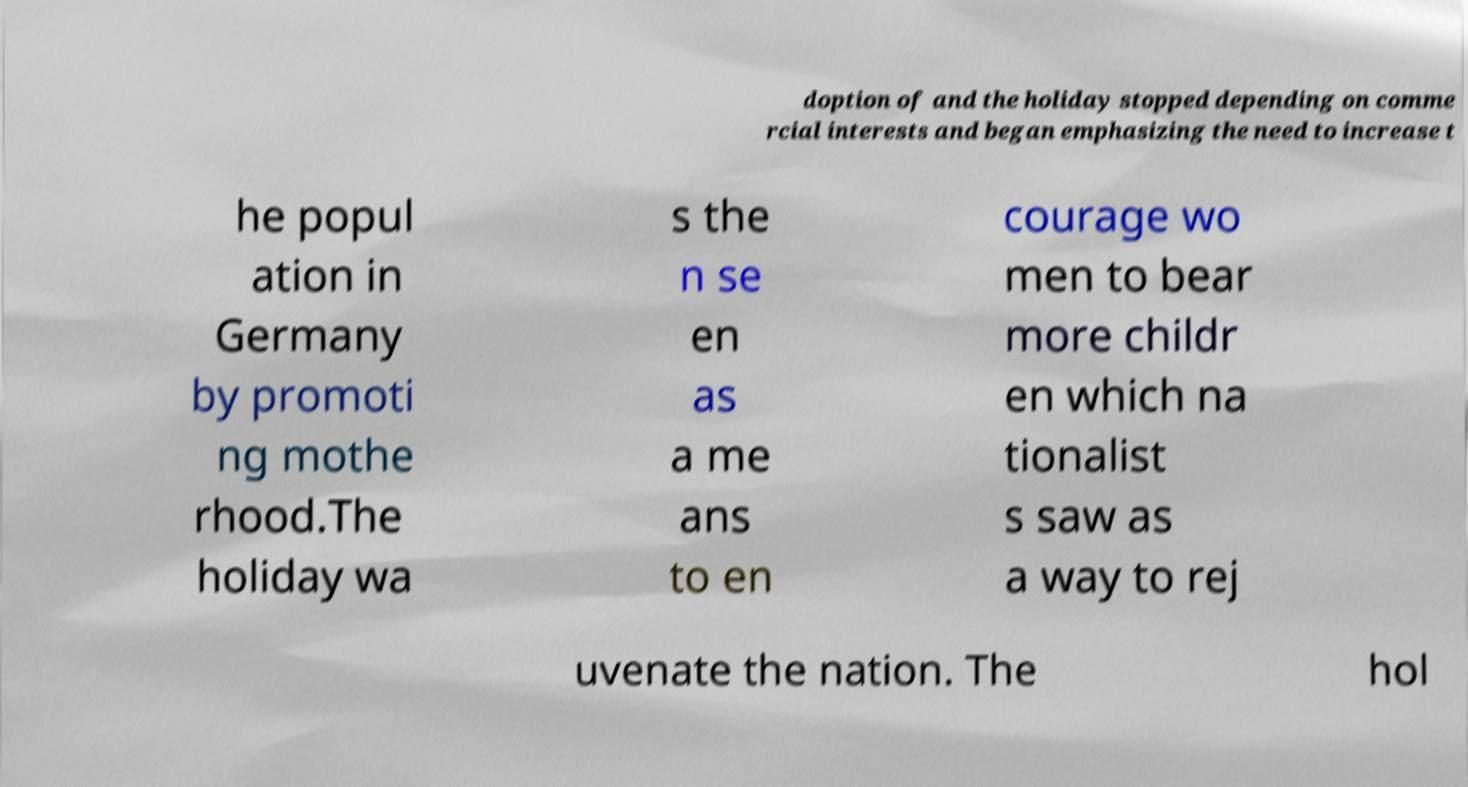There's text embedded in this image that I need extracted. Can you transcribe it verbatim? doption of and the holiday stopped depending on comme rcial interests and began emphasizing the need to increase t he popul ation in Germany by promoti ng mothe rhood.The holiday wa s the n se en as a me ans to en courage wo men to bear more childr en which na tionalist s saw as a way to rej uvenate the nation. The hol 